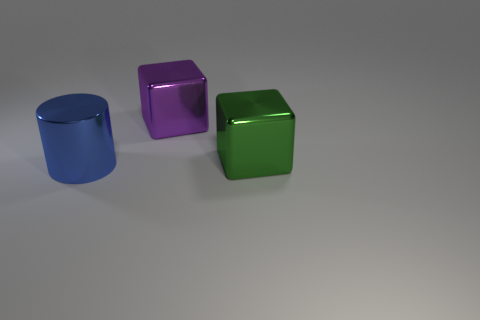Add 2 metal objects. How many objects exist? 5 Subtract all cylinders. How many objects are left? 2 Subtract 1 cubes. How many cubes are left? 1 Subtract 1 green cubes. How many objects are left? 2 Subtract all purple cubes. Subtract all green balls. How many cubes are left? 1 Subtract all yellow spheres. How many green cubes are left? 1 Subtract all blue things. Subtract all matte things. How many objects are left? 2 Add 3 large blue shiny things. How many large blue shiny things are left? 4 Add 2 cubes. How many cubes exist? 4 Subtract all purple cubes. How many cubes are left? 1 